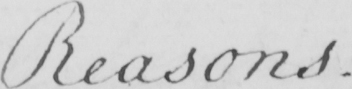Can you tell me what this handwritten text says? Reasons . 